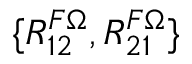Convert formula to latex. <formula><loc_0><loc_0><loc_500><loc_500>\{ R _ { 1 2 } ^ { F \Omega } , R _ { 2 1 } ^ { F \Omega } \}</formula> 